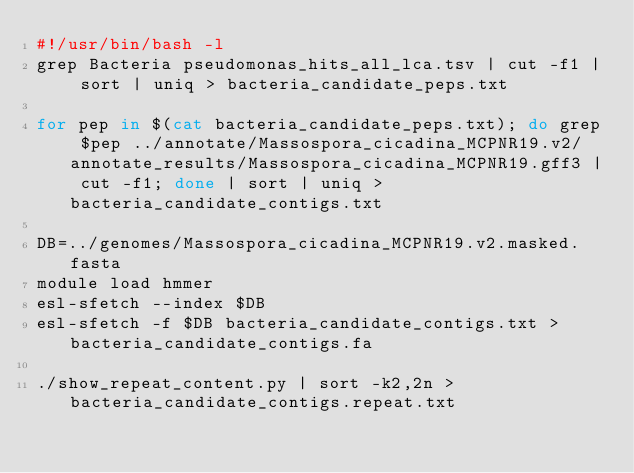<code> <loc_0><loc_0><loc_500><loc_500><_Bash_>#!/usr/bin/bash -l
grep Bacteria pseudomonas_hits_all_lca.tsv | cut -f1 | sort | uniq > bacteria_candidate_peps.txt

for pep in $(cat bacteria_candidate_peps.txt); do grep $pep ../annotate/Massospora_cicadina_MCPNR19.v2/annotate_results/Massospora_cicadina_MCPNR19.gff3 | cut -f1; done | sort | uniq > bacteria_candidate_contigs.txt

DB=../genomes/Massospora_cicadina_MCPNR19.v2.masked.fasta
module load hmmer
esl-sfetch --index $DB
esl-sfetch -f $DB bacteria_candidate_contigs.txt > bacteria_candidate_contigs.fa

./show_repeat_content.py | sort -k2,2n > bacteria_candidate_contigs.repeat.txt
</code> 